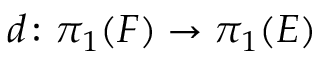<formula> <loc_0><loc_0><loc_500><loc_500>d \colon \pi _ { 1 } ( F ) \rightarrow \pi _ { 1 } ( E )</formula> 